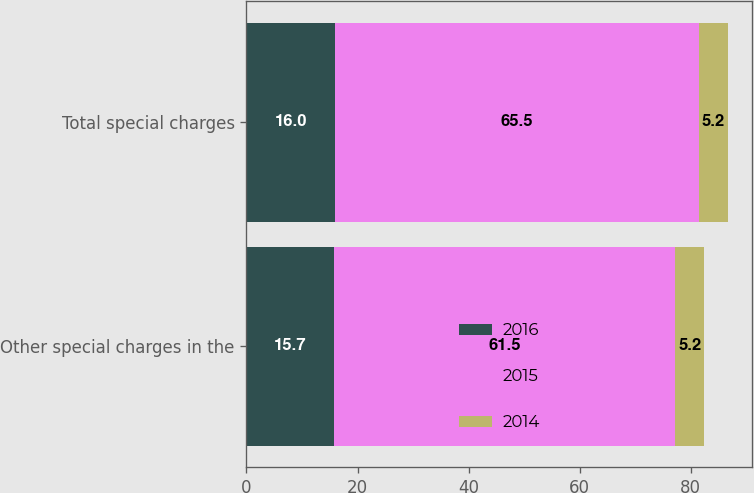Convert chart. <chart><loc_0><loc_0><loc_500><loc_500><stacked_bar_chart><ecel><fcel>Other special charges in the<fcel>Total special charges<nl><fcel>2016<fcel>15.7<fcel>16<nl><fcel>2015<fcel>61.5<fcel>65.5<nl><fcel>2014<fcel>5.2<fcel>5.2<nl></chart> 